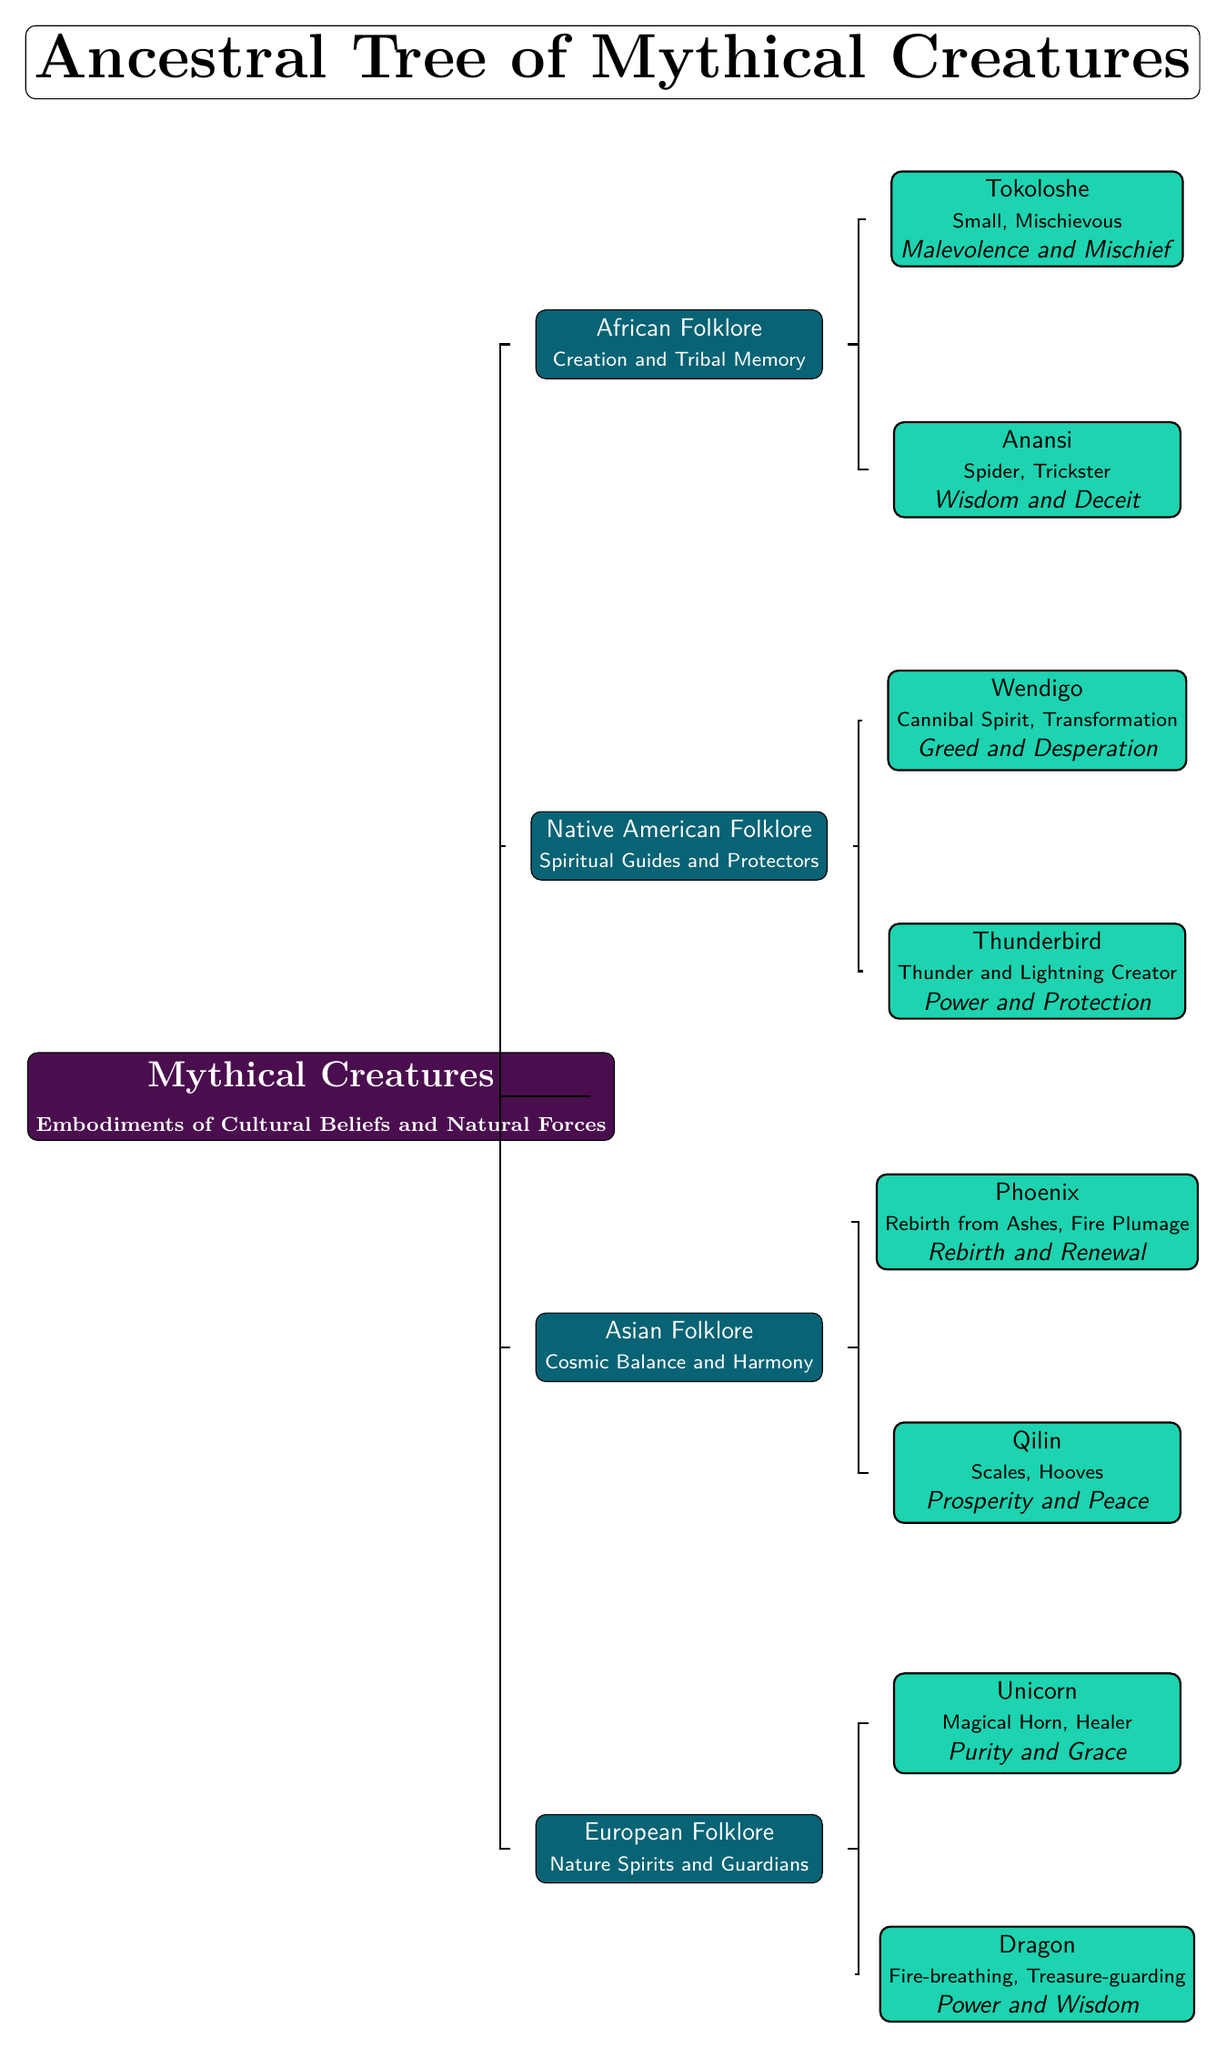What is the root title of the diagram? The diagram begins with a root node that has the title "Mythical Creatures" which introduces the overall theme.
Answer: Mythical Creatures How many branches are there in the diagram? There are four major branches originating from the root node, representing the different cultural folklore.
Answer: 4 What creature is associated with power and wisdom? The Dragon, which is labeled in the European Folklore section, is described as embodying power and wisdom.
Answer: Dragon Which folklore is represented by the Qilin? The Qilin is classified under Asian Folklore, noted for its attributes of prosperity and peace.
Answer: Asian Folklore What is the symbolic meaning of the Unicorn? The symbolic meaning ascribed to the Unicorn, found in the European Folklore branch, is purity and grace.
Answer: Purity and Grace How does the Thunderbird relate to other creatures? The Thunderbird, located in Native American Folklore, represents power and protection, indicating its significance as a spiritual guide compared to other creatures in this folklore.
Answer: Power and Protection What does Anansi symbolize in the diagram? Anansi is described as a spider trickster, symbolizing wisdom and deceit, which illustrates the dual nature of the folklore.
Answer: Wisdom and Deceit Which creature is associated with rebirth? The Phoenix, located in the Asian Folklore section, is known for its representation of rebirth and renewal in the diagram.
Answer: Phoenix What type of creature is the Tokoloshe? The Tokoloshe is identified as small and mischievous, reflecting its nature in the African Folklore section.
Answer: Small, Mischievous In which folklore does the Wendigo appear? The Wendigo is found in Native American Folklore, where it represents themes of greed and desperation.
Answer: Native American Folklore 